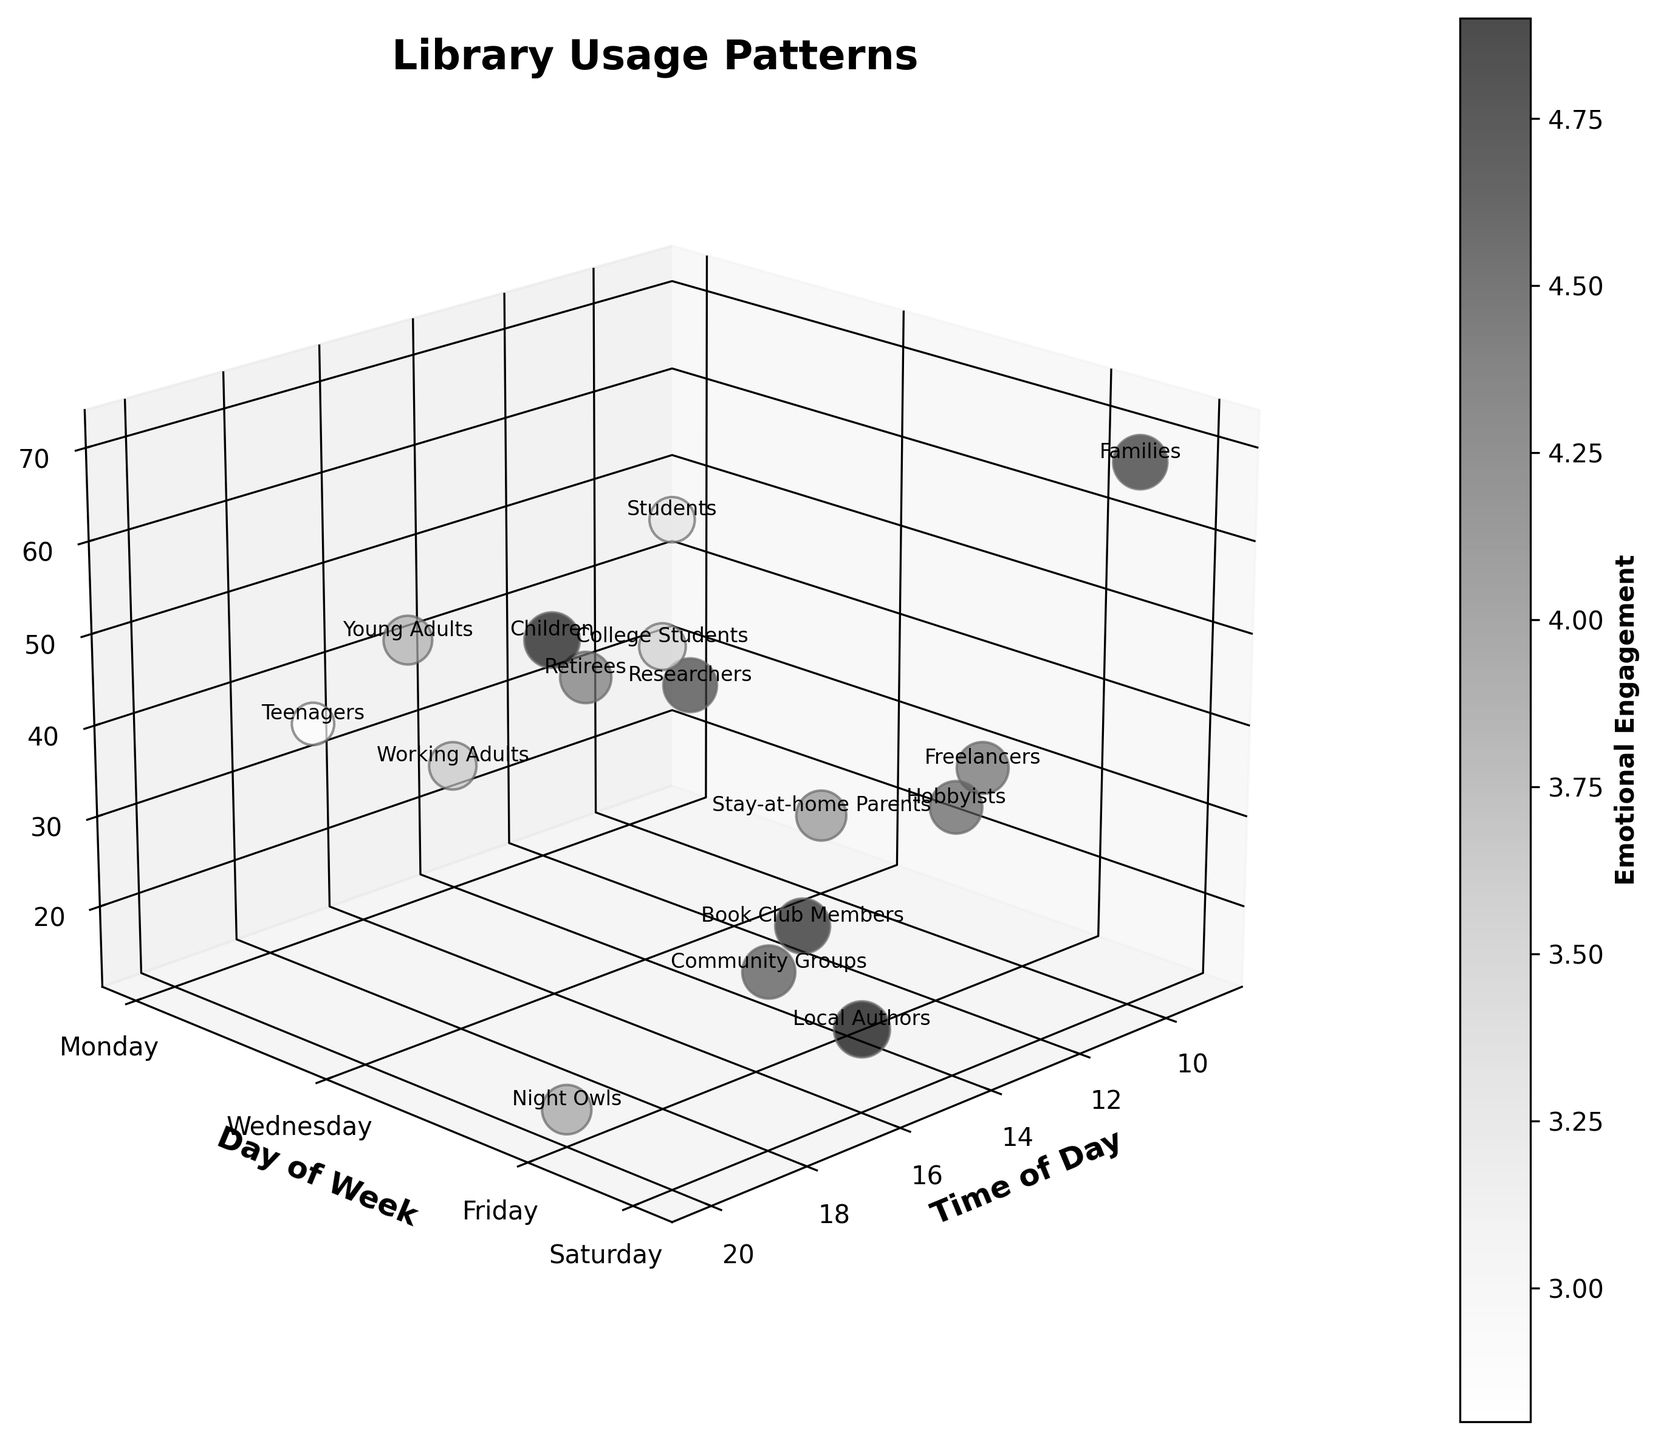What's the title of the figure? The title is written at the top of the figure in larger, bold letters.
Answer: Library Usage Patterns How is "Day of Week" represented in the figure? The "Day of Week" is represented along the y-axis, with specific days like Monday, Wednesday, Friday, and Saturday marked.
Answer: y-axis Which demographic has the highest Usage on Saturday? Observing the height of the bubbles along the z-axis for Saturday, the highest Usage bubble is for "Families".
Answer: Families Compare the Emotional Engagement for College Students and Night Owls on Friday. Which is higher? Comparing the size of the bubbles and their corresponding color on Friday, College Students have a lower Emotional Engagement compared to Night Owls.
Answer: Night Owls What value does the color bar represent? The color bar represents the Emotional Engagement, shown by the varying shades of gray.
Answer: Emotional Engagement On which day do Young Adults show up the most, and what is their Usage? By referring to the labels next to bubbles and hovering over Wednesday, Young Adults have the highest Usage, with a value of 55.
Answer: Wednesday, 55 Compare the Usage between Stay-at-home Parents on Wednesday and Community Groups on Saturday. Which has higher Usage? Looking at the positions along the z-axis for these groups, Stay-at-home Parents have a Usage of 20, whereas Community Groups have 30. Thus, Community Groups have higher Usage.
Answer: Community Groups What time of day sees the highest Usage on any given day? Observing the largest bubble along the z-axis across all times, the highest Usage occurs at 10:00 on Saturday for Families.
Answer: 10:00 on Saturday Which group has the highest Emotional Engagement score and on which day and time do they appear? The bubble with the largest size, indicating the highest Emotional Engagement, corresponds to Local Authors on Saturday at 16:00.
Answer: Local Authors, Saturday, 16:00 What is the overall trend in Usage for Fridays across different times? By examining the z-axis for all bubbles on Friday, the general trend shows increasing Usage from morning to evening, peaking at 18:00 with College Students.
Answer: Increasing trend, peaks at 18:00 